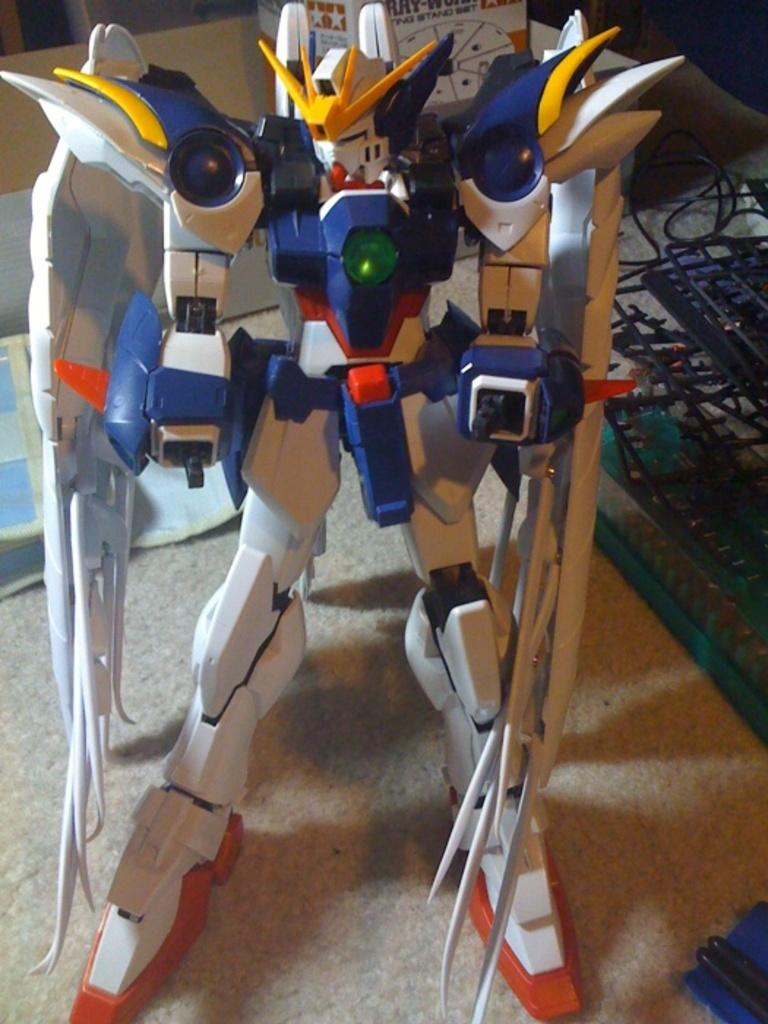What is on the table in the image? There is a toy on the table. What type of toy is it? The toy has a keyboard. Are there any other objects on the toy? Yes, there are other objects on the toy. Can you see any fish swimming in the bath in the image? There is no bath or fish present in the image; it features a toy with a keyboard and other objects. 